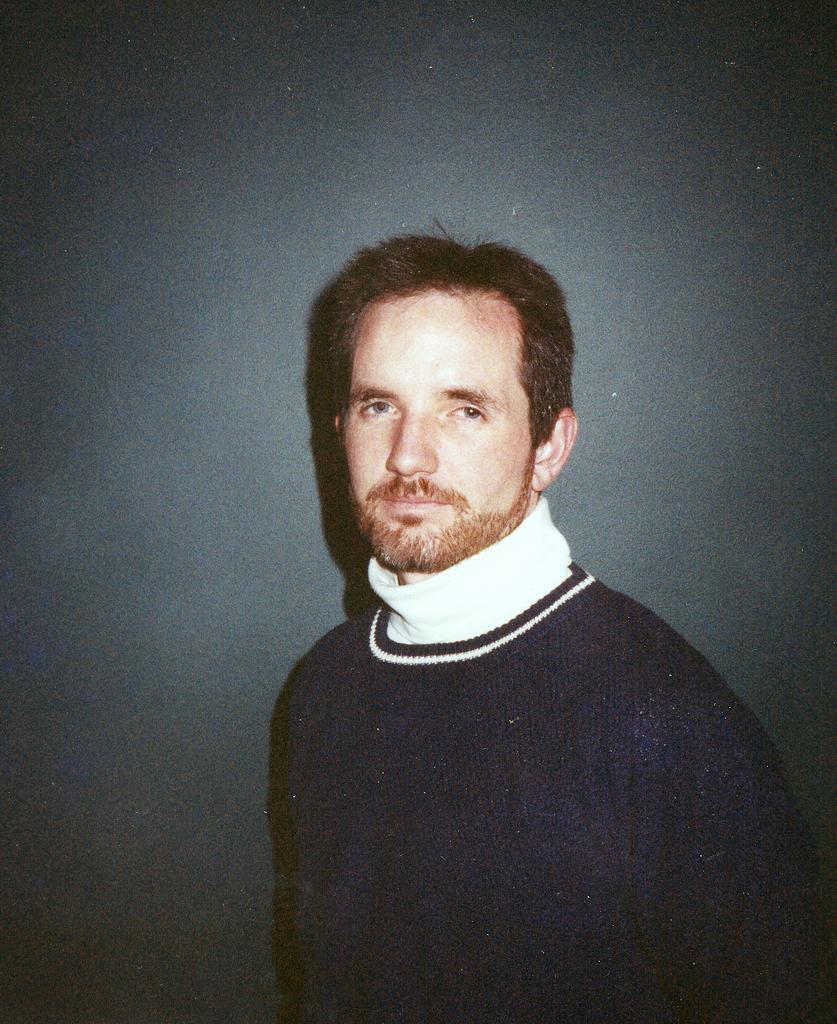Describe this image in one or two sentences. In this image there is a man standing in front of a wall. 